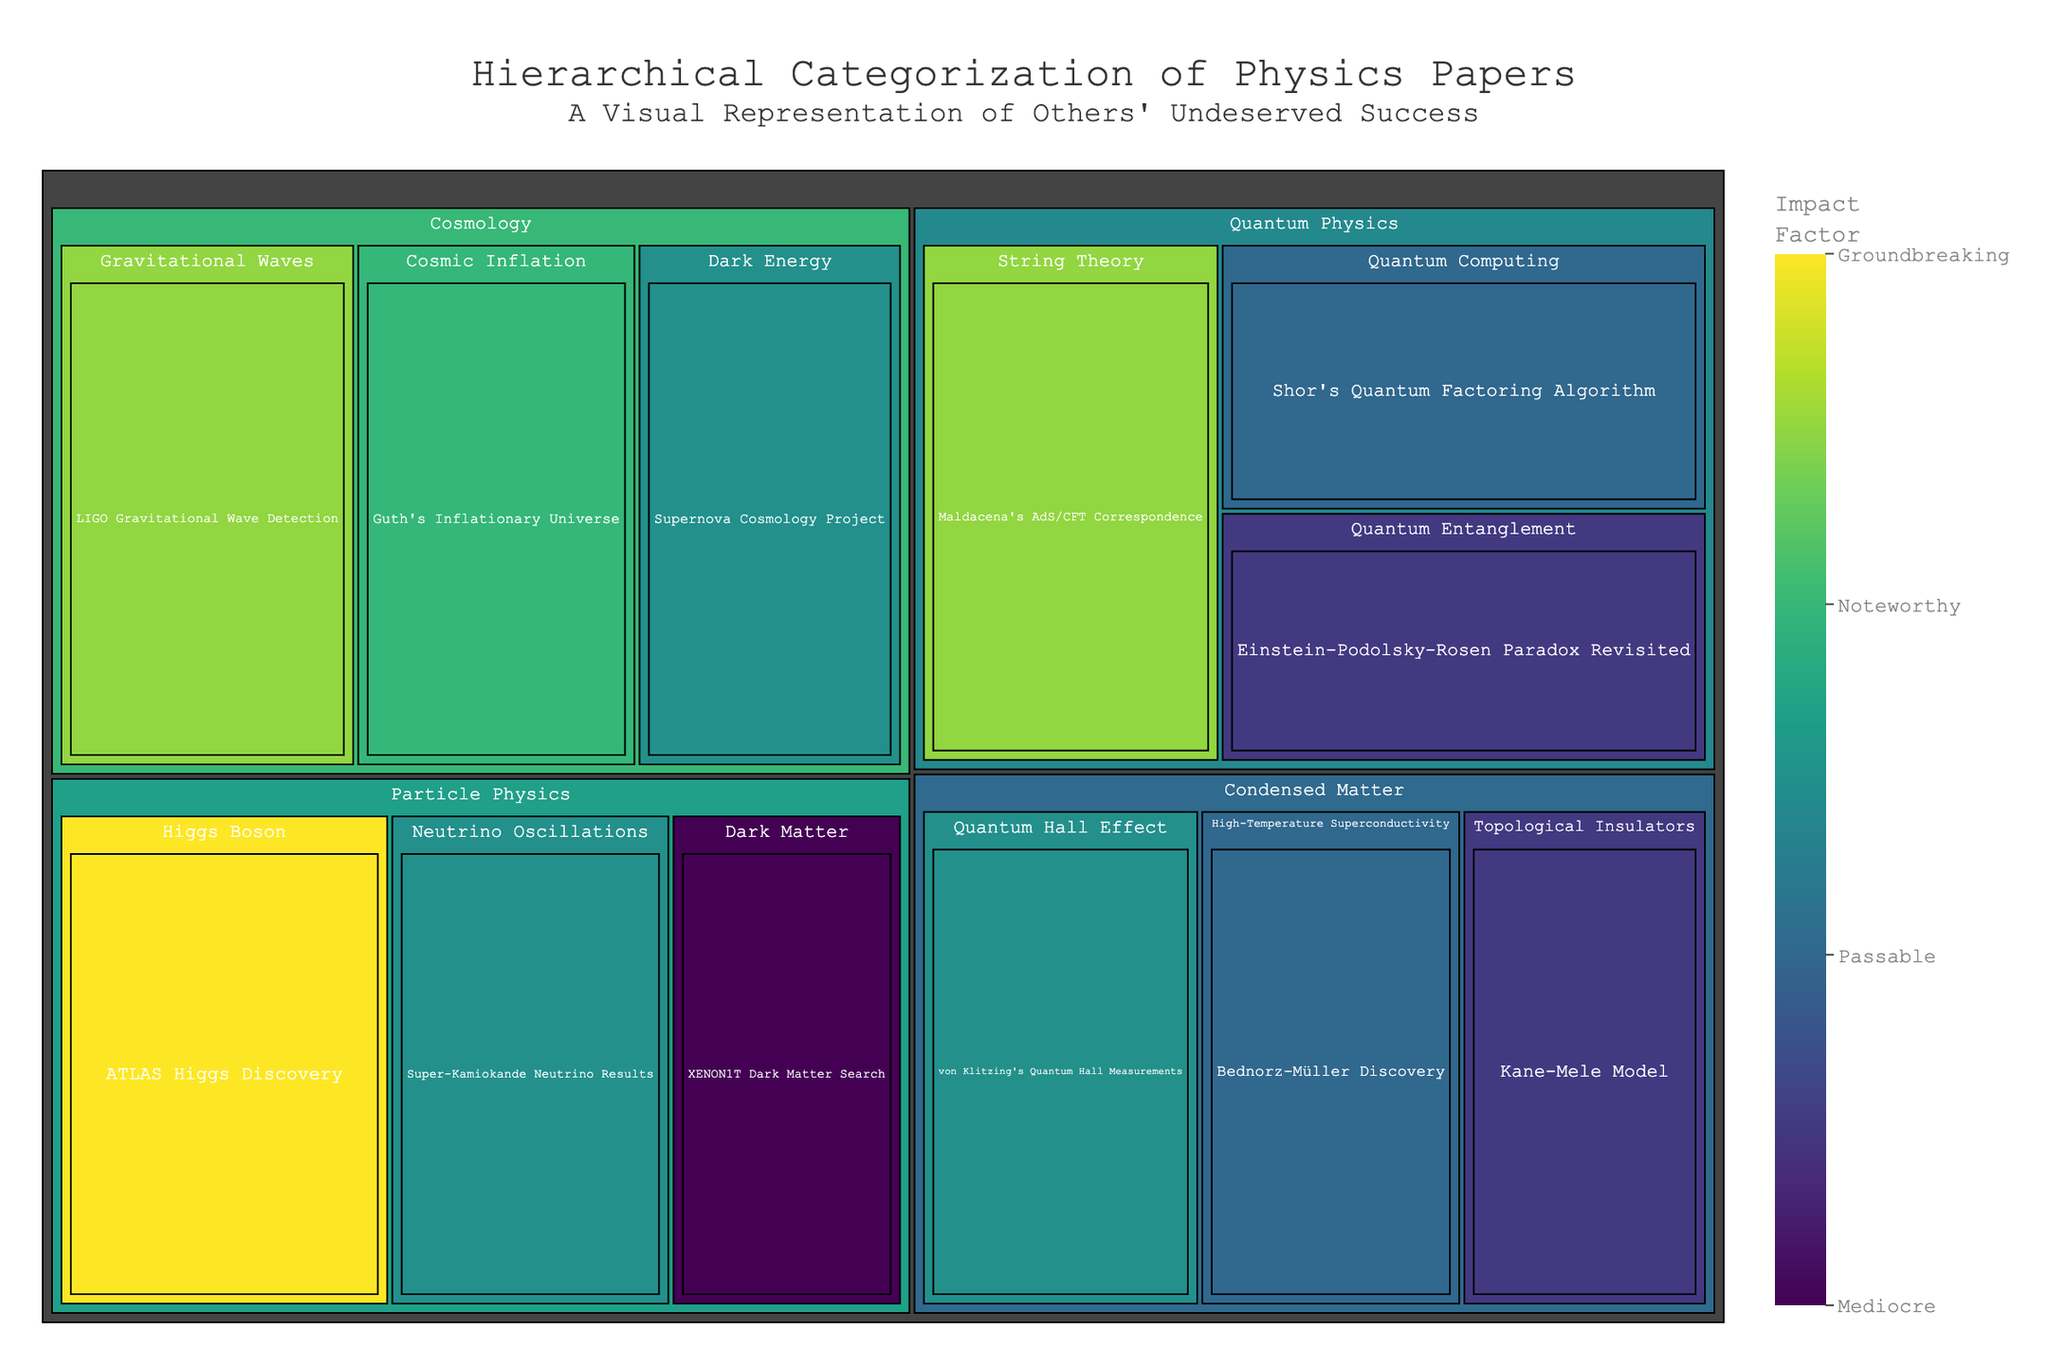What is the title of the treemap? The title is located at the top of the figure. It reads "Hierarchical Categorization of Physics Papers" followed by a subtitle "<sup>A Visual Representation of Others' Undeserved Success</sup>".
Answer: Hierarchical Categorization of Physics Papers Which category has the paper with the highest impact factor? By looking at the categories and the numerical values assigned to the papers in each category, the paper with the highest impact factor is "ATLAS Higgs Discovery" in the Particle Physics category with a value of 100.
Answer: Particle Physics What is the combined impact factor of all the papers in the Quantum Physics category? In the Quantum Physics category, the papers are "Maldacena's AdS/CFT Correspondence" (95), "Shor's Quantum Factoring Algorithm" (80), and "Einstein-Podolsky-Rosen Paradox Revisited" (75). Adding these values gives 95 + 80 + 75 = 250.
Answer: 250 Which subcategory in the Condensed Matter category has the greatest impact factor? Within the Condensed Matter category, the subcategories and their impact factors are: Topological Insulators (75 for "Kane-Mele Model"), High-Temperature Superconductivity (80 for "Bednorz-Müller Discovery"), and Quantum Hall Effect (85 for "von Klitzing's Quantum Hall Measurements"). The highest impact factor here is 85 for Quantum Hall Effect.
Answer: Quantum Hall Effect How does the impact factor of "LIGO Gravitational Wave Detection" compare to "Supernova Cosmology Project"? The impact factor of "LIGO Gravitational Wave Detection" is 95 and the impact factor of "Supernova Cosmology Project" is 85. Therefore, "LIGO Gravitational Wave Detection" has a higher impact factor.
Answer: LIGO Gravitational Wave Detection has a higher impact factor What is the average impact factor for papers in the Particle Physics category? The Particle Physics category has papers with impact factors of 100 ("ATLAS Higgs Discovery"), 85 ("Super-Kamiokande Neutrino Results"), and 70 ("XENON1T Dark Matter Search"). The average is calculated by (100 + 85 + 70) / 3 = 85.
Answer: 85 Which paper has a lower impact factor, "Guth's Inflationary Universe" or "Einstein-Podolsky-Rosen Paradox Revisited"? By comparing their impact factors, "Guth's Inflationary Universe" has an impact factor of 90 and "Einstein-Podolsky-Rosen Paradox Revisited" has an impact factor of 75. So, "Einstein-Podolsky-Rosen Paradox Revisited" has a lower impact factor.
Answer: Einstein-Podolsky-Rosen Paradox Revisited Explain how color is used to represent information in the treemap. The color in the treemap represents the impact factor of the papers. The color scale used is 'Viridis,' which ranges from lower values with darker shades to higher values with brighter shades. The color bar titled "Impact Factor" helps in understanding the range with descriptors like "Mediocre," "Passable," "Noteworthy," and "Groundbreaking."
Answer: Impact factor What is the total impact factor for all the papers in the Condensed Matter category? The papers in the Condensed Matter category have the following impact factors: 75 ("Kane-Mele Model"), 80 ("Bednorz-Müller Discovery"), and 85 ("von Klitzing's Quantum Hall Measurements"). The total impact factor is 75 + 80 + 85 = 240.
Answer: 240 